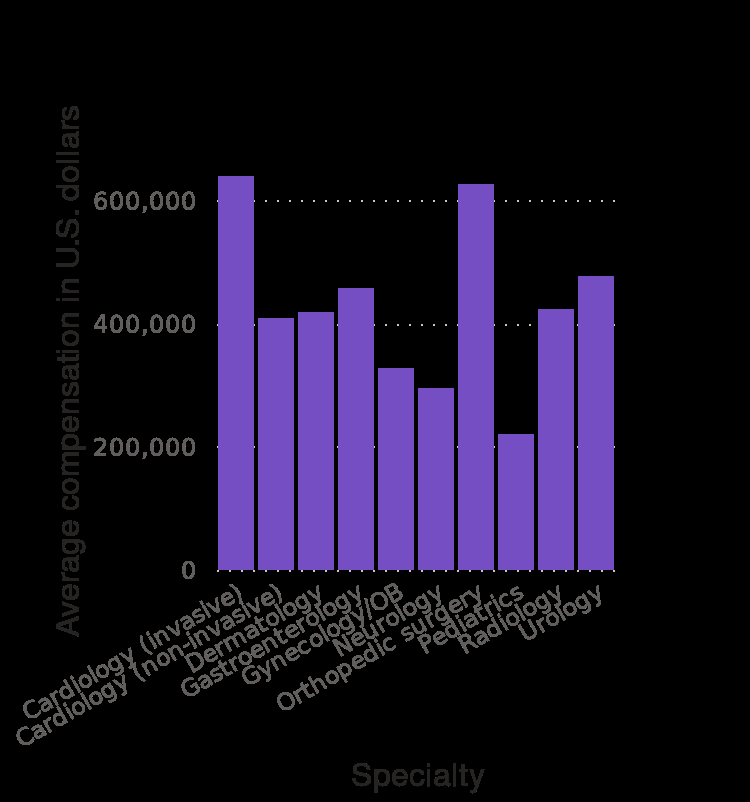<image>
please describe the details of the chart Here a bar graph is titled Average compensation offered to select top recruited U.S. physician specialties in 2019 - 2020 (in U.S. dollars). There is a linear scale of range 0 to 600,000 on the y-axis, labeled Average compensation in U.S. dollars. Along the x-axis, Specialty is drawn. please summary the statistics and relations of the chart Cardiology (invasive) and orthopaedic surgery harrods.com ve the highest compensation in physician specialities in the US. Whereas, Pediatrics have the lowest compensation. In which time period were the average compensations recorded for the physician specialties? The average compensations were recorded for the physician specialties in the time period of 2019 - 2020. 